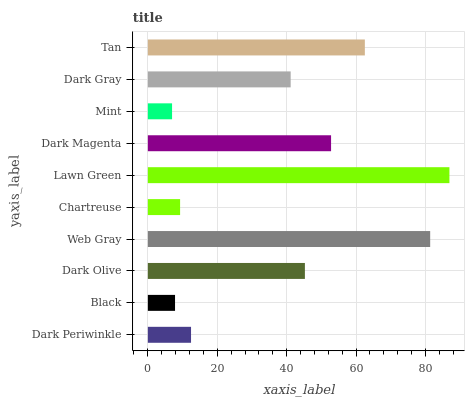Is Mint the minimum?
Answer yes or no. Yes. Is Lawn Green the maximum?
Answer yes or no. Yes. Is Black the minimum?
Answer yes or no. No. Is Black the maximum?
Answer yes or no. No. Is Dark Periwinkle greater than Black?
Answer yes or no. Yes. Is Black less than Dark Periwinkle?
Answer yes or no. Yes. Is Black greater than Dark Periwinkle?
Answer yes or no. No. Is Dark Periwinkle less than Black?
Answer yes or no. No. Is Dark Olive the high median?
Answer yes or no. Yes. Is Dark Gray the low median?
Answer yes or no. Yes. Is Lawn Green the high median?
Answer yes or no. No. Is Dark Periwinkle the low median?
Answer yes or no. No. 